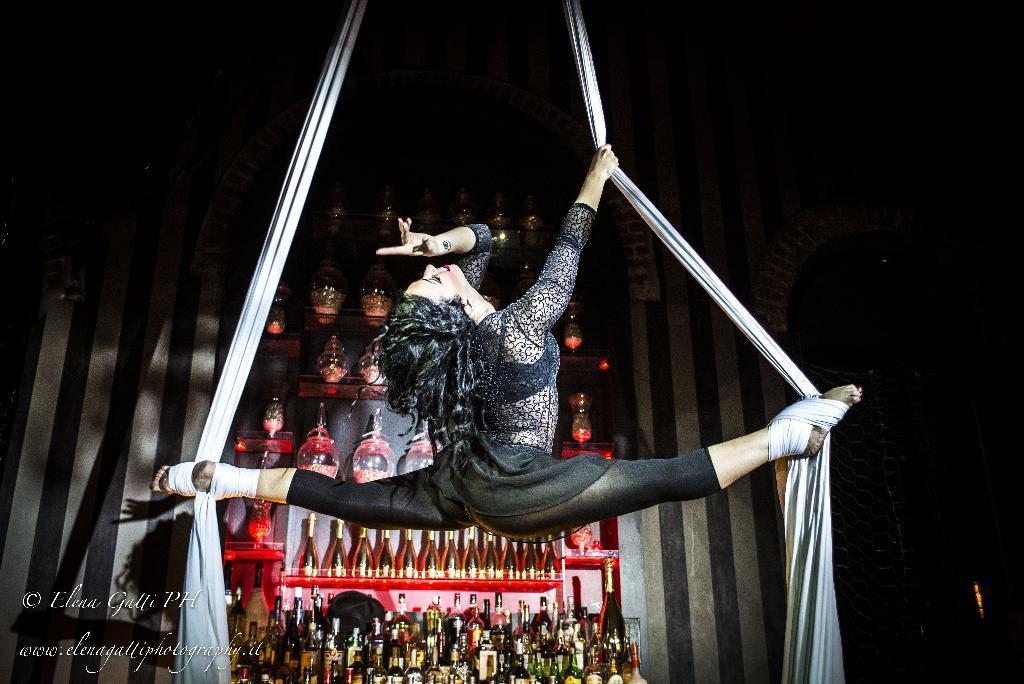Please provide a concise description of this image. In this picture I can see alcohol bottles on the racks in the background. I can see a woman doing the aerial silk dance. 